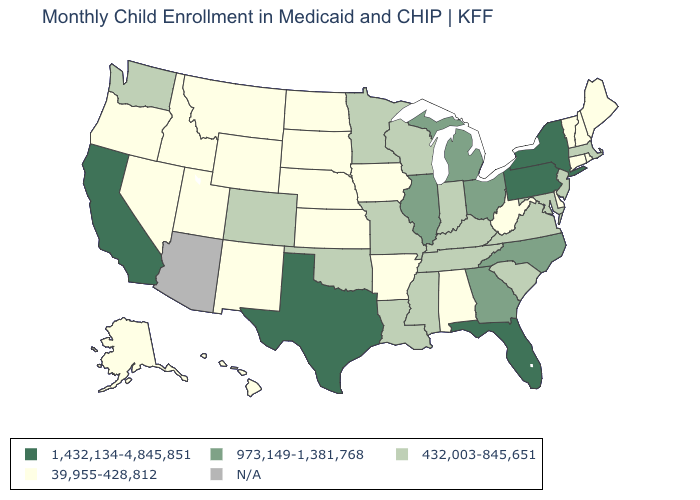What is the lowest value in the USA?
Answer briefly. 39,955-428,812. Name the states that have a value in the range 39,955-428,812?
Short answer required. Alabama, Alaska, Arkansas, Connecticut, Delaware, Hawaii, Idaho, Iowa, Kansas, Maine, Montana, Nebraska, Nevada, New Hampshire, New Mexico, North Dakota, Oregon, Rhode Island, South Dakota, Utah, Vermont, West Virginia, Wyoming. Does the first symbol in the legend represent the smallest category?
Keep it brief. No. Among the states that border Texas , which have the lowest value?
Concise answer only. Arkansas, New Mexico. What is the value of Alabama?
Quick response, please. 39,955-428,812. Which states have the lowest value in the Northeast?
Keep it brief. Connecticut, Maine, New Hampshire, Rhode Island, Vermont. What is the value of California?
Write a very short answer. 1,432,134-4,845,851. What is the value of Wisconsin?
Be succinct. 432,003-845,651. Name the states that have a value in the range 39,955-428,812?
Give a very brief answer. Alabama, Alaska, Arkansas, Connecticut, Delaware, Hawaii, Idaho, Iowa, Kansas, Maine, Montana, Nebraska, Nevada, New Hampshire, New Mexico, North Dakota, Oregon, Rhode Island, South Dakota, Utah, Vermont, West Virginia, Wyoming. What is the value of New Jersey?
Keep it brief. 432,003-845,651. Name the states that have a value in the range N/A?
Give a very brief answer. Arizona. Name the states that have a value in the range N/A?
Be succinct. Arizona. Which states have the lowest value in the South?
Be succinct. Alabama, Arkansas, Delaware, West Virginia. Name the states that have a value in the range 39,955-428,812?
Keep it brief. Alabama, Alaska, Arkansas, Connecticut, Delaware, Hawaii, Idaho, Iowa, Kansas, Maine, Montana, Nebraska, Nevada, New Hampshire, New Mexico, North Dakota, Oregon, Rhode Island, South Dakota, Utah, Vermont, West Virginia, Wyoming. Is the legend a continuous bar?
Concise answer only. No. 